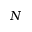Convert formula to latex. <formula><loc_0><loc_0><loc_500><loc_500>N</formula> 